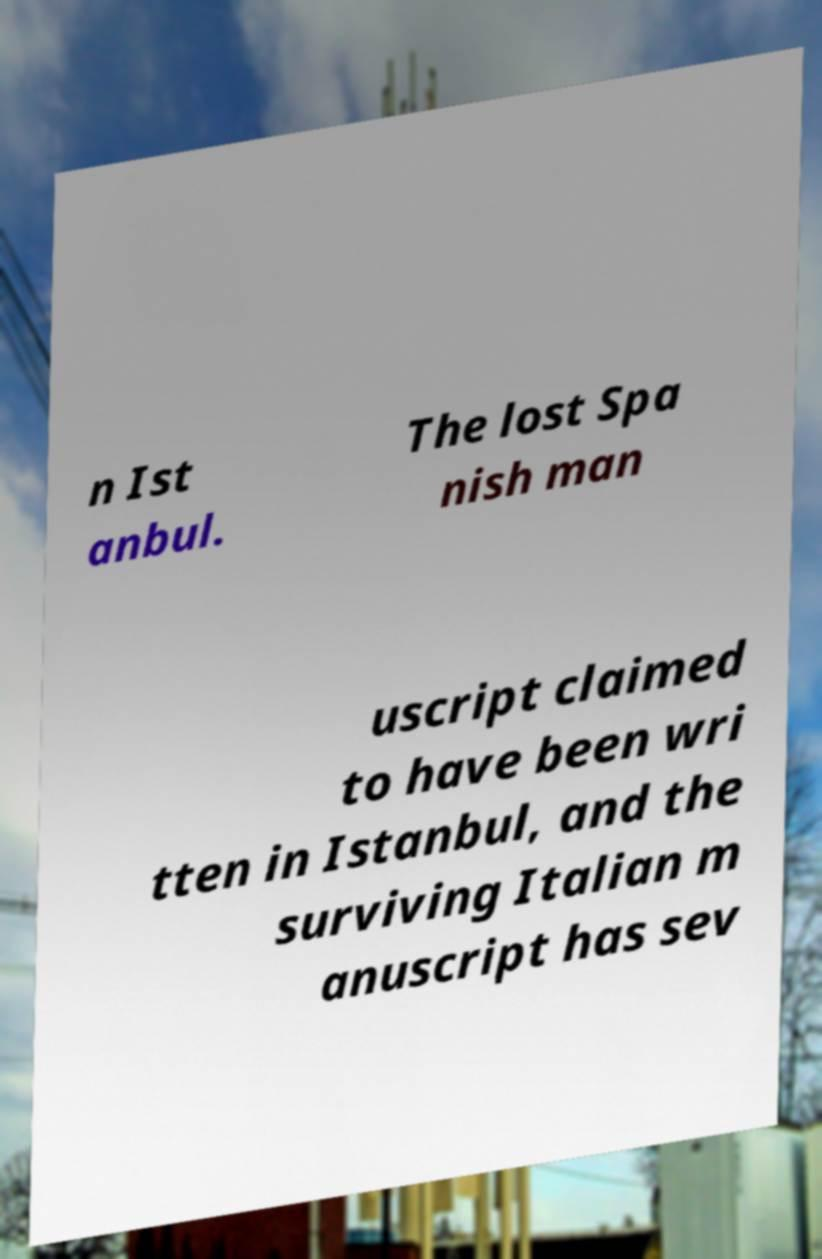Can you accurately transcribe the text from the provided image for me? n Ist anbul. The lost Spa nish man uscript claimed to have been wri tten in Istanbul, and the surviving Italian m anuscript has sev 